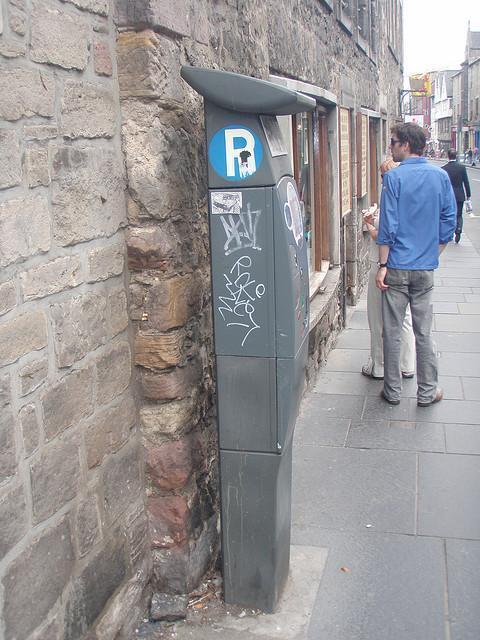How many parking meters are in the picture?
Give a very brief answer. 1. 